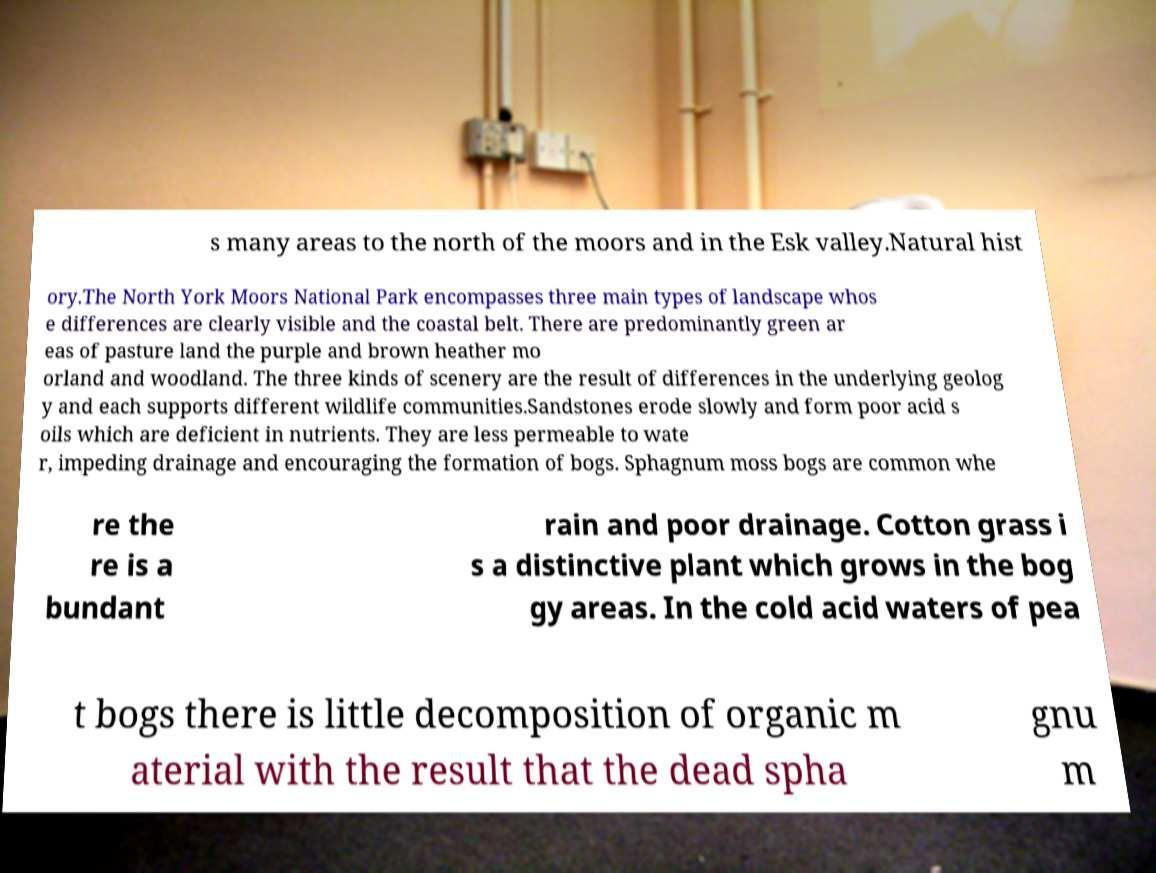What messages or text are displayed in this image? I need them in a readable, typed format. s many areas to the north of the moors and in the Esk valley.Natural hist ory.The North York Moors National Park encompasses three main types of landscape whos e differences are clearly visible and the coastal belt. There are predominantly green ar eas of pasture land the purple and brown heather mo orland and woodland. The three kinds of scenery are the result of differences in the underlying geolog y and each supports different wildlife communities.Sandstones erode slowly and form poor acid s oils which are deficient in nutrients. They are less permeable to wate r, impeding drainage and encouraging the formation of bogs. Sphagnum moss bogs are common whe re the re is a bundant rain and poor drainage. Cotton grass i s a distinctive plant which grows in the bog gy areas. In the cold acid waters of pea t bogs there is little decomposition of organic m aterial with the result that the dead spha gnu m 